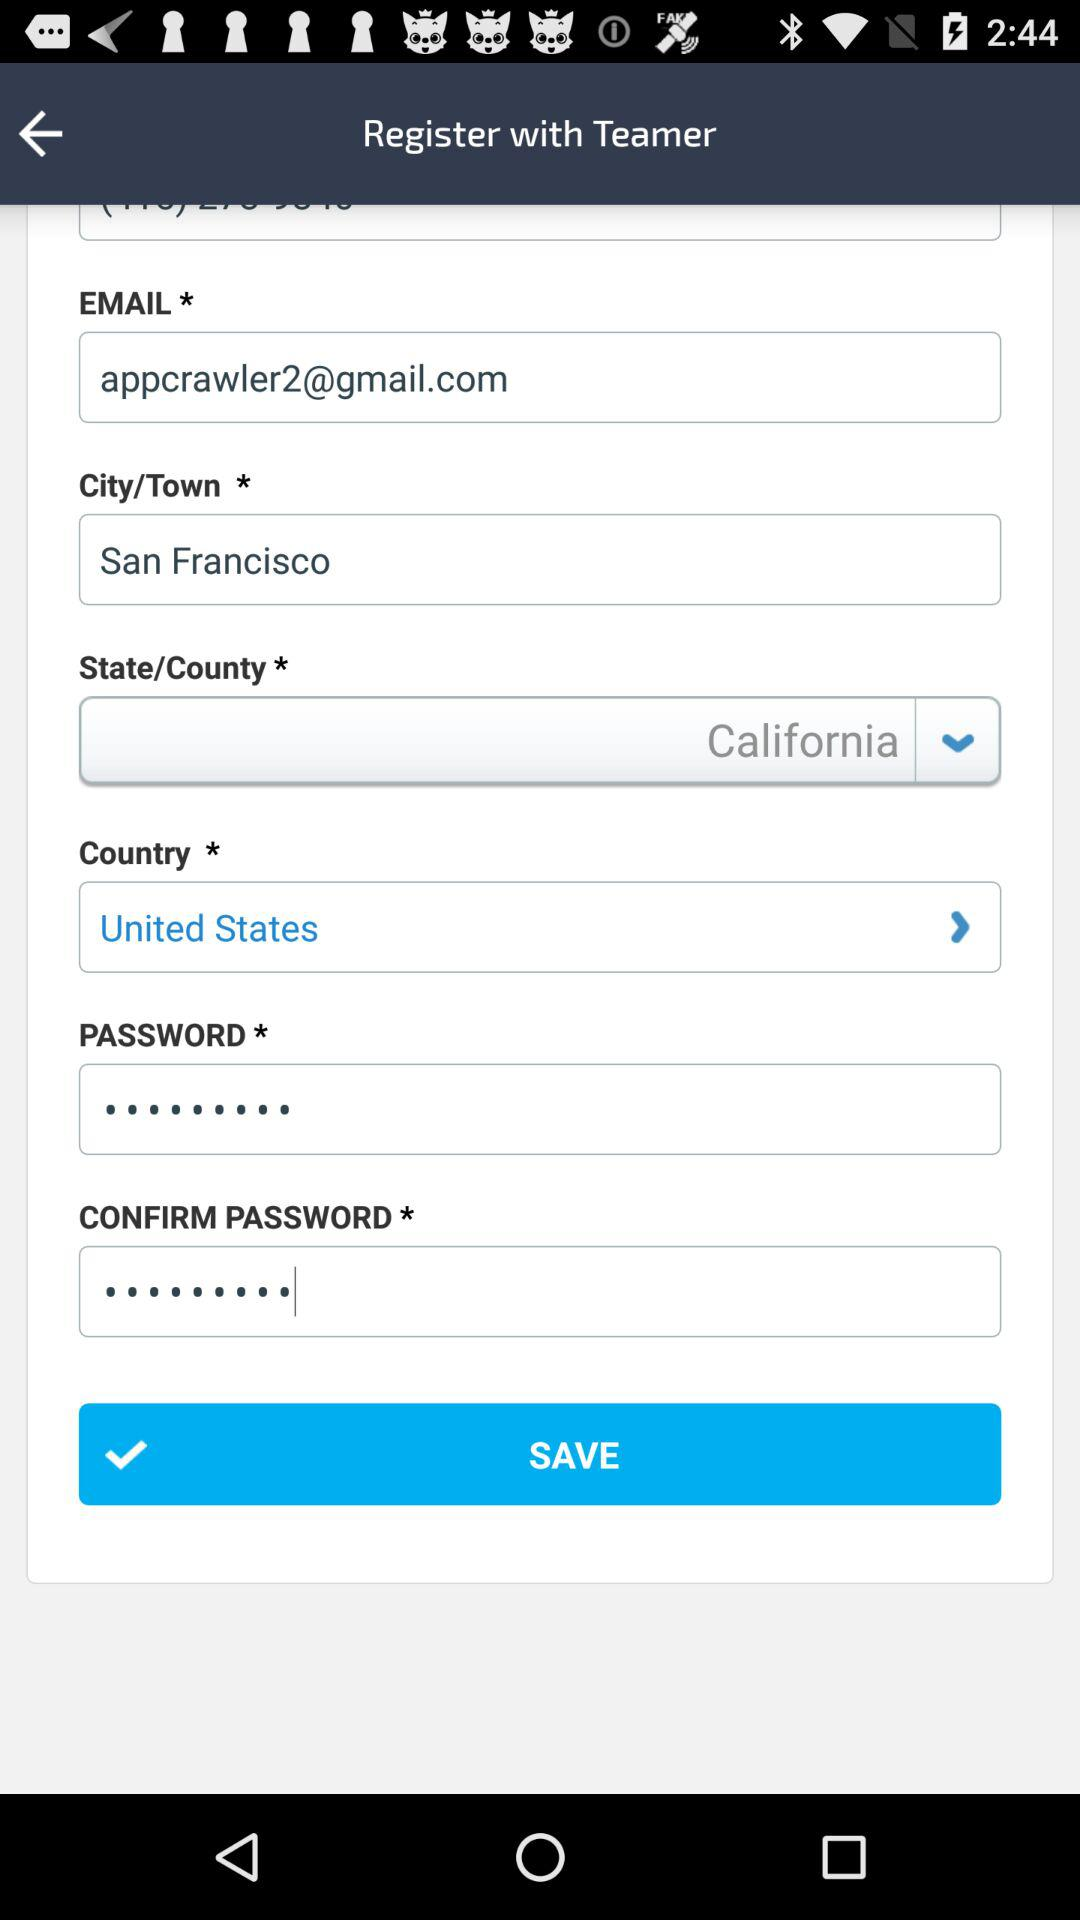What's the name of the city? The name of the city is San Francisco. 